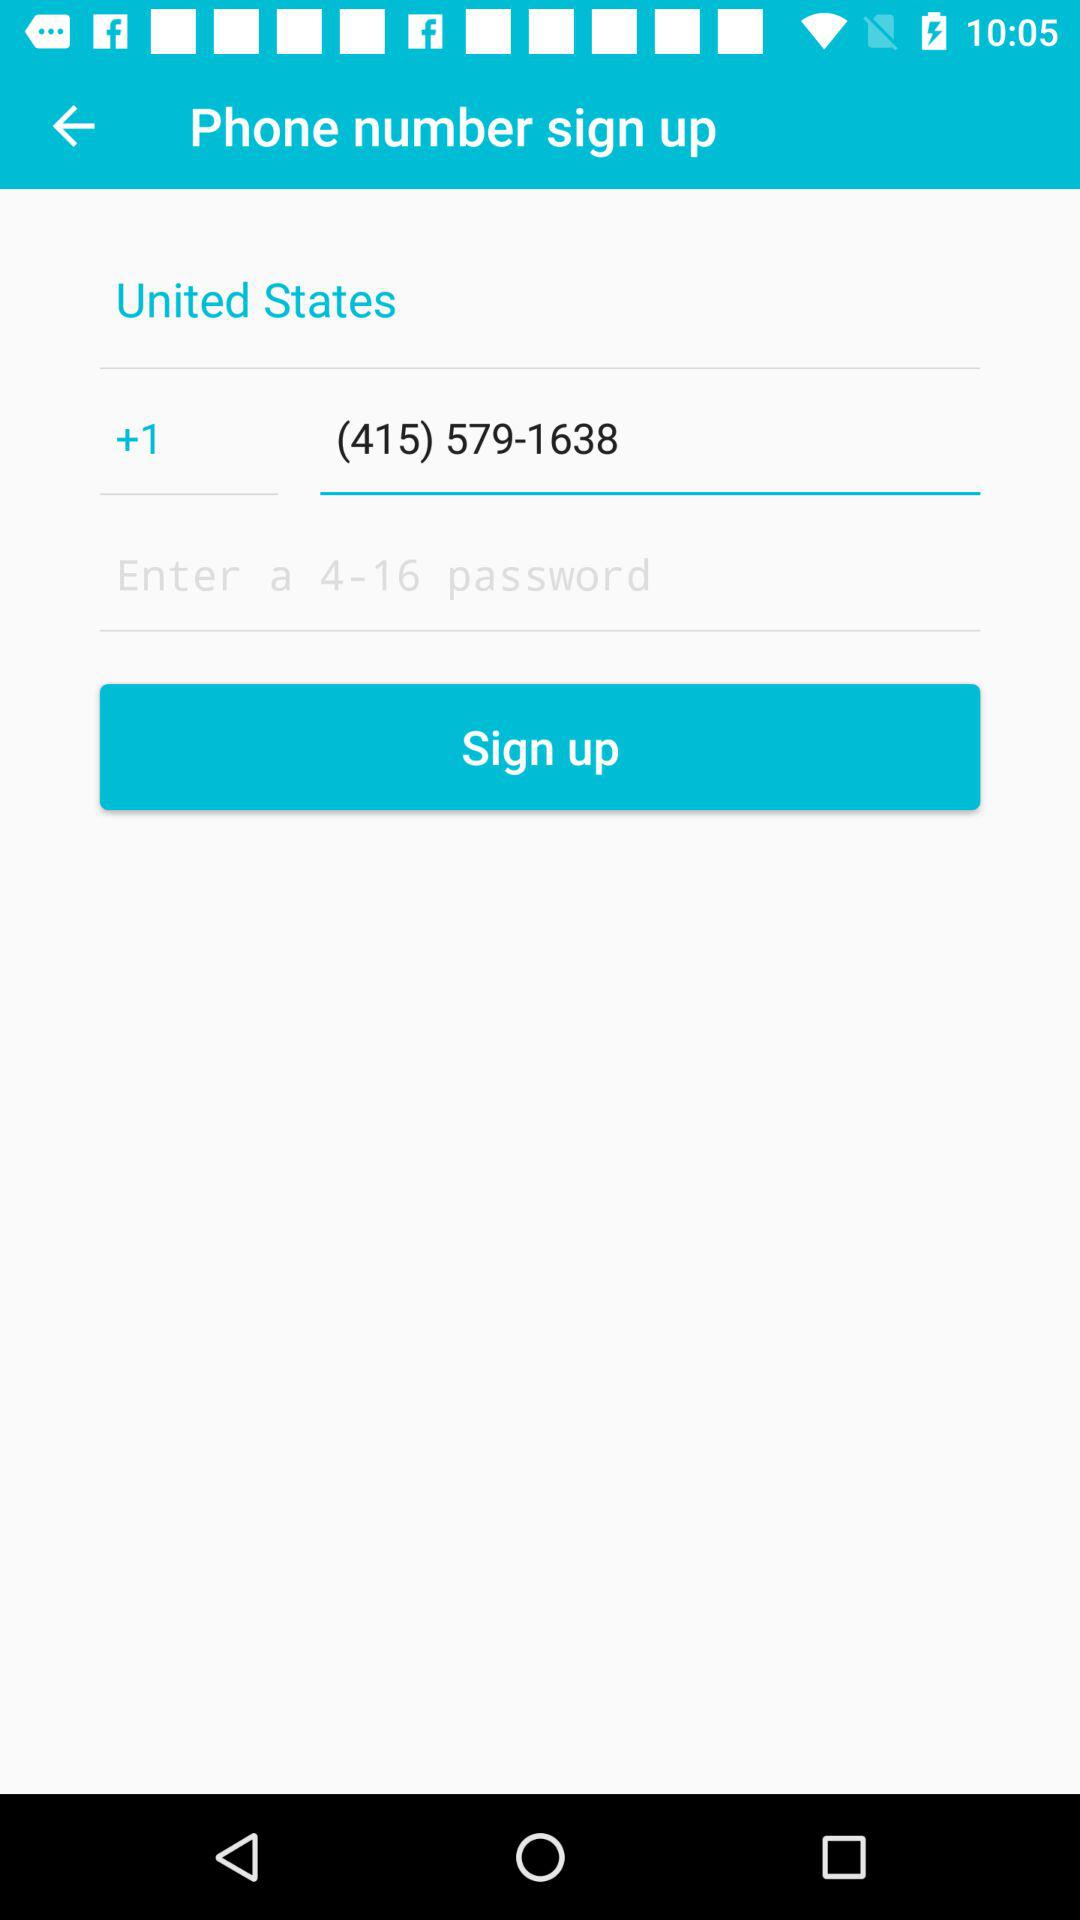What country code is used? The country code used is (415) 579-1638. 